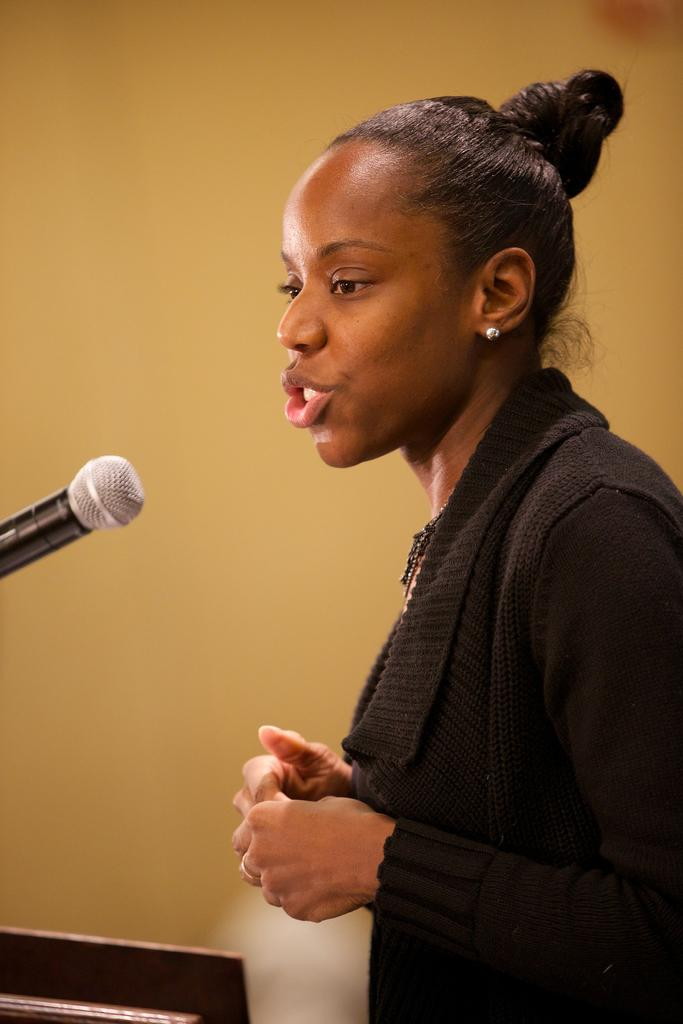Who is the main subject in the image? There is a girl in the image. What is the girl doing in the image? The girl is standing in front of a mic. What can be seen in the background of the image? There is a wall in the background of the image. What type of quilt is draped over the girl's shoulders in the image? There is no quilt present in the image; the girl is standing in front of a mic. What is the texture of the ground in the image? The image does not show the ground, so it is not possible to determine its texture. 